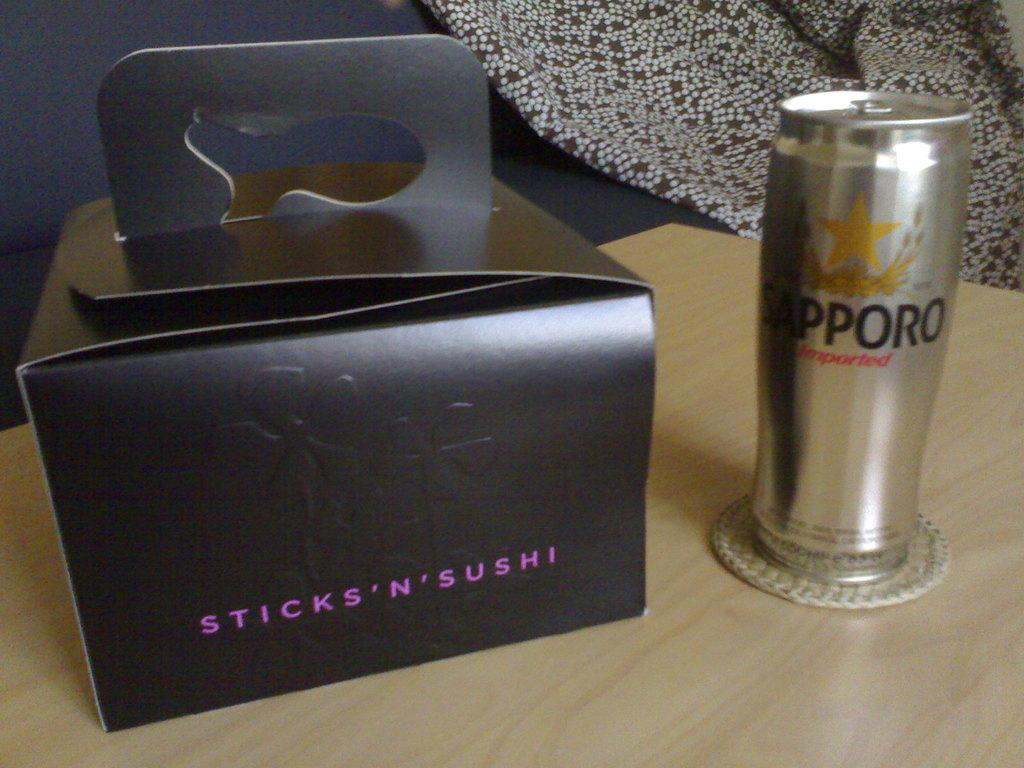<image>
Write a terse but informative summary of the picture. A black, closed Sticks'N'Sushi box sitting on the table next to some type of beverage. 